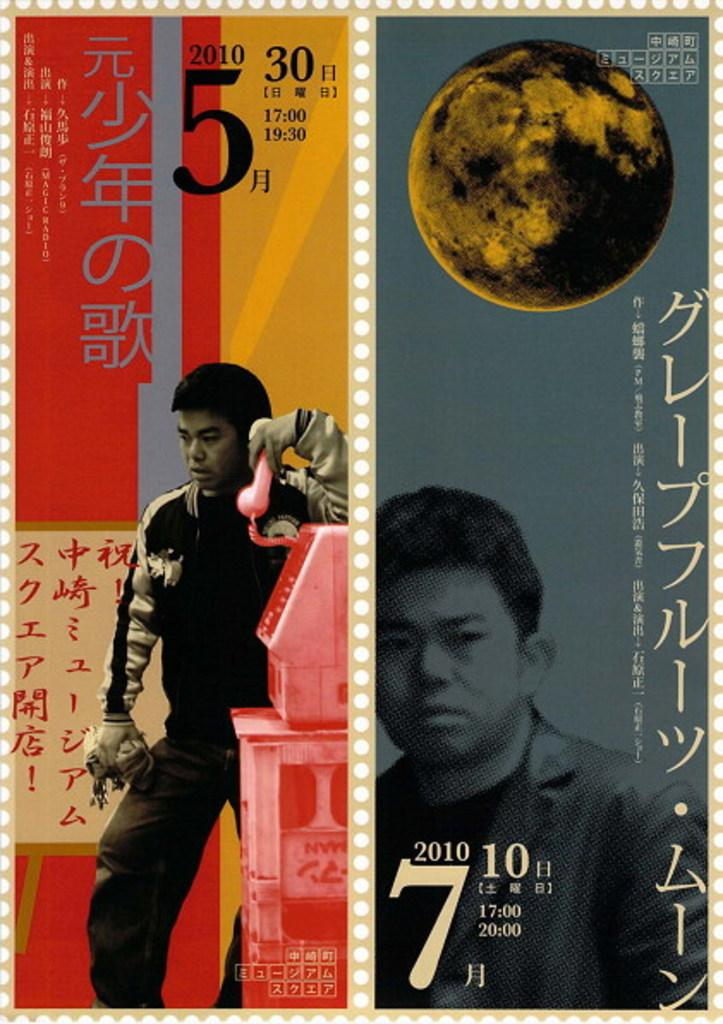<image>
Share a concise interpretation of the image provided. A calendar in chinese with a man pictured is advertising the year 2010. 